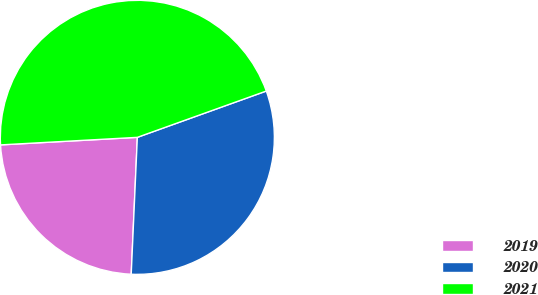Convert chart to OTSL. <chart><loc_0><loc_0><loc_500><loc_500><pie_chart><fcel>2019<fcel>2020<fcel>2021<nl><fcel>23.41%<fcel>31.2%<fcel>45.39%<nl></chart> 